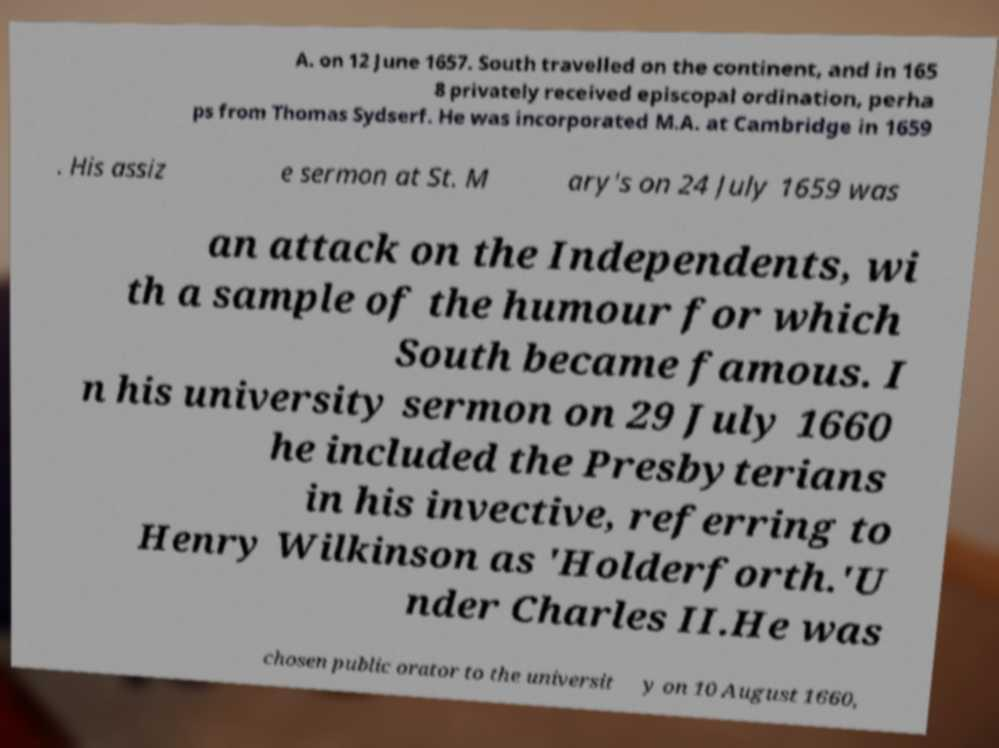There's text embedded in this image that I need extracted. Can you transcribe it verbatim? A. on 12 June 1657. South travelled on the continent, and in 165 8 privately received episcopal ordination, perha ps from Thomas Sydserf. He was incorporated M.A. at Cambridge in 1659 . His assiz e sermon at St. M ary's on 24 July 1659 was an attack on the Independents, wi th a sample of the humour for which South became famous. I n his university sermon on 29 July 1660 he included the Presbyterians in his invective, referring to Henry Wilkinson as 'Holderforth.'U nder Charles II.He was chosen public orator to the universit y on 10 August 1660, 